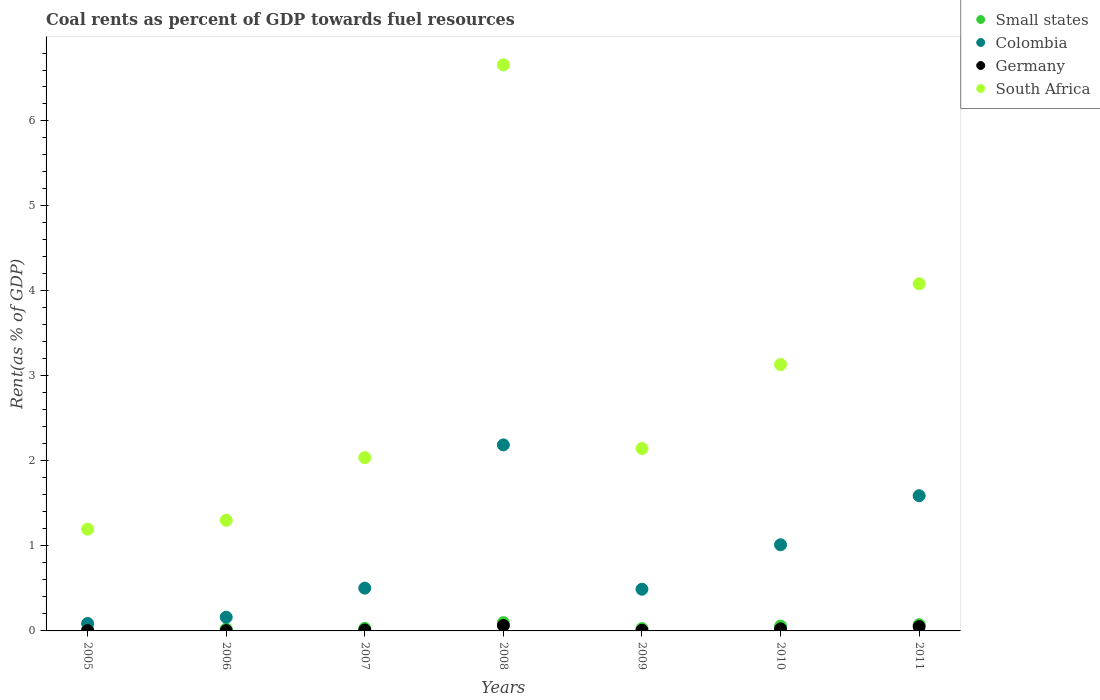How many different coloured dotlines are there?
Make the answer very short. 4. Is the number of dotlines equal to the number of legend labels?
Provide a succinct answer. Yes. What is the coal rent in Small states in 2009?
Keep it short and to the point. 0.03. Across all years, what is the maximum coal rent in Small states?
Offer a terse response. 0.1. Across all years, what is the minimum coal rent in Small states?
Provide a short and direct response. 0.02. In which year was the coal rent in South Africa minimum?
Provide a succinct answer. 2005. What is the total coal rent in Colombia in the graph?
Ensure brevity in your answer.  6.04. What is the difference between the coal rent in Colombia in 2008 and that in 2009?
Your answer should be compact. 1.7. What is the difference between the coal rent in Small states in 2006 and the coal rent in Germany in 2009?
Provide a short and direct response. 0.02. What is the average coal rent in Colombia per year?
Your response must be concise. 0.86. In the year 2005, what is the difference between the coal rent in Germany and coal rent in Small states?
Provide a short and direct response. -0.02. In how many years, is the coal rent in Colombia greater than 3.6 %?
Ensure brevity in your answer.  0. What is the ratio of the coal rent in Colombia in 2006 to that in 2011?
Ensure brevity in your answer.  0.1. Is the coal rent in Small states in 2006 less than that in 2011?
Give a very brief answer. Yes. Is the difference between the coal rent in Germany in 2007 and 2008 greater than the difference between the coal rent in Small states in 2007 and 2008?
Offer a terse response. Yes. What is the difference between the highest and the second highest coal rent in Small states?
Ensure brevity in your answer.  0.02. What is the difference between the highest and the lowest coal rent in Germany?
Your answer should be very brief. 0.06. In how many years, is the coal rent in Small states greater than the average coal rent in Small states taken over all years?
Your answer should be compact. 3. Is it the case that in every year, the sum of the coal rent in Germany and coal rent in South Africa  is greater than the sum of coal rent in Colombia and coal rent in Small states?
Keep it short and to the point. Yes. Does the coal rent in Small states monotonically increase over the years?
Offer a very short reply. No. Is the coal rent in Germany strictly greater than the coal rent in Small states over the years?
Your response must be concise. No. Is the coal rent in Small states strictly less than the coal rent in Colombia over the years?
Provide a short and direct response. Yes. How many dotlines are there?
Make the answer very short. 4. How many years are there in the graph?
Offer a terse response. 7. What is the difference between two consecutive major ticks on the Y-axis?
Provide a short and direct response. 1. Does the graph contain grids?
Make the answer very short. No. How are the legend labels stacked?
Ensure brevity in your answer.  Vertical. What is the title of the graph?
Offer a very short reply. Coal rents as percent of GDP towards fuel resources. What is the label or title of the X-axis?
Provide a short and direct response. Years. What is the label or title of the Y-axis?
Keep it short and to the point. Rent(as % of GDP). What is the Rent(as % of GDP) in Small states in 2005?
Your response must be concise. 0.02. What is the Rent(as % of GDP) in Colombia in 2005?
Your response must be concise. 0.09. What is the Rent(as % of GDP) of Germany in 2005?
Your answer should be very brief. 0. What is the Rent(as % of GDP) of South Africa in 2005?
Your answer should be very brief. 1.2. What is the Rent(as % of GDP) of Small states in 2006?
Keep it short and to the point. 0.02. What is the Rent(as % of GDP) in Colombia in 2006?
Your answer should be very brief. 0.16. What is the Rent(as % of GDP) of Germany in 2006?
Offer a very short reply. 0. What is the Rent(as % of GDP) of South Africa in 2006?
Make the answer very short. 1.3. What is the Rent(as % of GDP) in Small states in 2007?
Provide a short and direct response. 0.03. What is the Rent(as % of GDP) in Colombia in 2007?
Offer a terse response. 0.5. What is the Rent(as % of GDP) in Germany in 2007?
Make the answer very short. 0.01. What is the Rent(as % of GDP) of South Africa in 2007?
Provide a short and direct response. 2.04. What is the Rent(as % of GDP) of Small states in 2008?
Your response must be concise. 0.1. What is the Rent(as % of GDP) in Colombia in 2008?
Offer a terse response. 2.19. What is the Rent(as % of GDP) in Germany in 2008?
Your answer should be compact. 0.06. What is the Rent(as % of GDP) of South Africa in 2008?
Provide a succinct answer. 6.66. What is the Rent(as % of GDP) of Small states in 2009?
Provide a short and direct response. 0.03. What is the Rent(as % of GDP) in Colombia in 2009?
Your answer should be very brief. 0.49. What is the Rent(as % of GDP) of Germany in 2009?
Your answer should be very brief. 0.01. What is the Rent(as % of GDP) in South Africa in 2009?
Provide a short and direct response. 2.15. What is the Rent(as % of GDP) of Small states in 2010?
Offer a very short reply. 0.06. What is the Rent(as % of GDP) of Colombia in 2010?
Provide a succinct answer. 1.01. What is the Rent(as % of GDP) in Germany in 2010?
Your answer should be very brief. 0.02. What is the Rent(as % of GDP) of South Africa in 2010?
Your response must be concise. 3.13. What is the Rent(as % of GDP) in Small states in 2011?
Ensure brevity in your answer.  0.07. What is the Rent(as % of GDP) in Colombia in 2011?
Keep it short and to the point. 1.59. What is the Rent(as % of GDP) of Germany in 2011?
Your answer should be compact. 0.05. What is the Rent(as % of GDP) of South Africa in 2011?
Offer a very short reply. 4.08. Across all years, what is the maximum Rent(as % of GDP) in Small states?
Offer a very short reply. 0.1. Across all years, what is the maximum Rent(as % of GDP) in Colombia?
Offer a very short reply. 2.19. Across all years, what is the maximum Rent(as % of GDP) of Germany?
Keep it short and to the point. 0.06. Across all years, what is the maximum Rent(as % of GDP) in South Africa?
Your answer should be very brief. 6.66. Across all years, what is the minimum Rent(as % of GDP) in Small states?
Provide a succinct answer. 0.02. Across all years, what is the minimum Rent(as % of GDP) in Colombia?
Make the answer very short. 0.09. Across all years, what is the minimum Rent(as % of GDP) of Germany?
Ensure brevity in your answer.  0. Across all years, what is the minimum Rent(as % of GDP) in South Africa?
Give a very brief answer. 1.2. What is the total Rent(as % of GDP) of Small states in the graph?
Provide a short and direct response. 0.33. What is the total Rent(as % of GDP) in Colombia in the graph?
Make the answer very short. 6.04. What is the total Rent(as % of GDP) in Germany in the graph?
Provide a succinct answer. 0.16. What is the total Rent(as % of GDP) of South Africa in the graph?
Provide a succinct answer. 20.56. What is the difference between the Rent(as % of GDP) of Small states in 2005 and that in 2006?
Provide a succinct answer. -0. What is the difference between the Rent(as % of GDP) in Colombia in 2005 and that in 2006?
Give a very brief answer. -0.07. What is the difference between the Rent(as % of GDP) of Germany in 2005 and that in 2006?
Give a very brief answer. -0. What is the difference between the Rent(as % of GDP) in South Africa in 2005 and that in 2006?
Your answer should be compact. -0.1. What is the difference between the Rent(as % of GDP) of Small states in 2005 and that in 2007?
Ensure brevity in your answer.  -0.01. What is the difference between the Rent(as % of GDP) of Colombia in 2005 and that in 2007?
Make the answer very short. -0.42. What is the difference between the Rent(as % of GDP) of Germany in 2005 and that in 2007?
Your answer should be very brief. -0.01. What is the difference between the Rent(as % of GDP) of South Africa in 2005 and that in 2007?
Your answer should be compact. -0.84. What is the difference between the Rent(as % of GDP) in Small states in 2005 and that in 2008?
Make the answer very short. -0.08. What is the difference between the Rent(as % of GDP) of Colombia in 2005 and that in 2008?
Make the answer very short. -2.1. What is the difference between the Rent(as % of GDP) of Germany in 2005 and that in 2008?
Give a very brief answer. -0.06. What is the difference between the Rent(as % of GDP) of South Africa in 2005 and that in 2008?
Your response must be concise. -5.46. What is the difference between the Rent(as % of GDP) of Small states in 2005 and that in 2009?
Make the answer very short. -0.01. What is the difference between the Rent(as % of GDP) of Colombia in 2005 and that in 2009?
Make the answer very short. -0.4. What is the difference between the Rent(as % of GDP) of Germany in 2005 and that in 2009?
Ensure brevity in your answer.  -0. What is the difference between the Rent(as % of GDP) of South Africa in 2005 and that in 2009?
Ensure brevity in your answer.  -0.95. What is the difference between the Rent(as % of GDP) in Small states in 2005 and that in 2010?
Your answer should be compact. -0.04. What is the difference between the Rent(as % of GDP) of Colombia in 2005 and that in 2010?
Keep it short and to the point. -0.93. What is the difference between the Rent(as % of GDP) of Germany in 2005 and that in 2010?
Keep it short and to the point. -0.02. What is the difference between the Rent(as % of GDP) of South Africa in 2005 and that in 2010?
Your answer should be very brief. -1.94. What is the difference between the Rent(as % of GDP) in Small states in 2005 and that in 2011?
Provide a short and direct response. -0.05. What is the difference between the Rent(as % of GDP) in Colombia in 2005 and that in 2011?
Your answer should be compact. -1.5. What is the difference between the Rent(as % of GDP) of Germany in 2005 and that in 2011?
Make the answer very short. -0.05. What is the difference between the Rent(as % of GDP) of South Africa in 2005 and that in 2011?
Provide a short and direct response. -2.89. What is the difference between the Rent(as % of GDP) in Small states in 2006 and that in 2007?
Provide a succinct answer. -0.01. What is the difference between the Rent(as % of GDP) of Colombia in 2006 and that in 2007?
Your answer should be compact. -0.34. What is the difference between the Rent(as % of GDP) of Germany in 2006 and that in 2007?
Offer a very short reply. -0.01. What is the difference between the Rent(as % of GDP) in South Africa in 2006 and that in 2007?
Give a very brief answer. -0.74. What is the difference between the Rent(as % of GDP) of Small states in 2006 and that in 2008?
Your answer should be compact. -0.07. What is the difference between the Rent(as % of GDP) of Colombia in 2006 and that in 2008?
Provide a succinct answer. -2.03. What is the difference between the Rent(as % of GDP) of Germany in 2006 and that in 2008?
Offer a very short reply. -0.06. What is the difference between the Rent(as % of GDP) in South Africa in 2006 and that in 2008?
Provide a succinct answer. -5.36. What is the difference between the Rent(as % of GDP) of Small states in 2006 and that in 2009?
Provide a succinct answer. -0. What is the difference between the Rent(as % of GDP) in Colombia in 2006 and that in 2009?
Your answer should be very brief. -0.33. What is the difference between the Rent(as % of GDP) of Germany in 2006 and that in 2009?
Your answer should be very brief. -0. What is the difference between the Rent(as % of GDP) of South Africa in 2006 and that in 2009?
Provide a short and direct response. -0.84. What is the difference between the Rent(as % of GDP) of Small states in 2006 and that in 2010?
Your response must be concise. -0.03. What is the difference between the Rent(as % of GDP) of Colombia in 2006 and that in 2010?
Keep it short and to the point. -0.85. What is the difference between the Rent(as % of GDP) of Germany in 2006 and that in 2010?
Give a very brief answer. -0.02. What is the difference between the Rent(as % of GDP) in South Africa in 2006 and that in 2010?
Your answer should be very brief. -1.83. What is the difference between the Rent(as % of GDP) of Colombia in 2006 and that in 2011?
Your response must be concise. -1.43. What is the difference between the Rent(as % of GDP) in Germany in 2006 and that in 2011?
Offer a very short reply. -0.05. What is the difference between the Rent(as % of GDP) in South Africa in 2006 and that in 2011?
Your answer should be compact. -2.78. What is the difference between the Rent(as % of GDP) of Small states in 2007 and that in 2008?
Offer a very short reply. -0.07. What is the difference between the Rent(as % of GDP) of Colombia in 2007 and that in 2008?
Ensure brevity in your answer.  -1.69. What is the difference between the Rent(as % of GDP) in Germany in 2007 and that in 2008?
Make the answer very short. -0.05. What is the difference between the Rent(as % of GDP) in South Africa in 2007 and that in 2008?
Provide a succinct answer. -4.62. What is the difference between the Rent(as % of GDP) of Small states in 2007 and that in 2009?
Your answer should be very brief. 0. What is the difference between the Rent(as % of GDP) of Colombia in 2007 and that in 2009?
Offer a terse response. 0.01. What is the difference between the Rent(as % of GDP) of Germany in 2007 and that in 2009?
Your answer should be very brief. 0. What is the difference between the Rent(as % of GDP) of South Africa in 2007 and that in 2009?
Provide a succinct answer. -0.11. What is the difference between the Rent(as % of GDP) of Small states in 2007 and that in 2010?
Your answer should be compact. -0.03. What is the difference between the Rent(as % of GDP) in Colombia in 2007 and that in 2010?
Provide a short and direct response. -0.51. What is the difference between the Rent(as % of GDP) of Germany in 2007 and that in 2010?
Ensure brevity in your answer.  -0.01. What is the difference between the Rent(as % of GDP) in South Africa in 2007 and that in 2010?
Offer a very short reply. -1.1. What is the difference between the Rent(as % of GDP) of Small states in 2007 and that in 2011?
Keep it short and to the point. -0.04. What is the difference between the Rent(as % of GDP) of Colombia in 2007 and that in 2011?
Offer a terse response. -1.09. What is the difference between the Rent(as % of GDP) in Germany in 2007 and that in 2011?
Give a very brief answer. -0.04. What is the difference between the Rent(as % of GDP) in South Africa in 2007 and that in 2011?
Keep it short and to the point. -2.05. What is the difference between the Rent(as % of GDP) in Small states in 2008 and that in 2009?
Your answer should be compact. 0.07. What is the difference between the Rent(as % of GDP) in Colombia in 2008 and that in 2009?
Keep it short and to the point. 1.7. What is the difference between the Rent(as % of GDP) of Germany in 2008 and that in 2009?
Provide a succinct answer. 0.06. What is the difference between the Rent(as % of GDP) of South Africa in 2008 and that in 2009?
Offer a very short reply. 4.51. What is the difference between the Rent(as % of GDP) of Small states in 2008 and that in 2010?
Your response must be concise. 0.04. What is the difference between the Rent(as % of GDP) in Colombia in 2008 and that in 2010?
Your response must be concise. 1.18. What is the difference between the Rent(as % of GDP) in Germany in 2008 and that in 2010?
Your answer should be compact. 0.04. What is the difference between the Rent(as % of GDP) in South Africa in 2008 and that in 2010?
Your answer should be compact. 3.53. What is the difference between the Rent(as % of GDP) in Small states in 2008 and that in 2011?
Ensure brevity in your answer.  0.02. What is the difference between the Rent(as % of GDP) of Colombia in 2008 and that in 2011?
Give a very brief answer. 0.6. What is the difference between the Rent(as % of GDP) of Germany in 2008 and that in 2011?
Give a very brief answer. 0.01. What is the difference between the Rent(as % of GDP) in South Africa in 2008 and that in 2011?
Your response must be concise. 2.58. What is the difference between the Rent(as % of GDP) of Small states in 2009 and that in 2010?
Ensure brevity in your answer.  -0.03. What is the difference between the Rent(as % of GDP) of Colombia in 2009 and that in 2010?
Provide a short and direct response. -0.52. What is the difference between the Rent(as % of GDP) in Germany in 2009 and that in 2010?
Provide a short and direct response. -0.02. What is the difference between the Rent(as % of GDP) in South Africa in 2009 and that in 2010?
Provide a short and direct response. -0.99. What is the difference between the Rent(as % of GDP) of Small states in 2009 and that in 2011?
Make the answer very short. -0.05. What is the difference between the Rent(as % of GDP) in Colombia in 2009 and that in 2011?
Your answer should be compact. -1.1. What is the difference between the Rent(as % of GDP) of Germany in 2009 and that in 2011?
Provide a short and direct response. -0.04. What is the difference between the Rent(as % of GDP) in South Africa in 2009 and that in 2011?
Offer a very short reply. -1.94. What is the difference between the Rent(as % of GDP) in Small states in 2010 and that in 2011?
Provide a succinct answer. -0.02. What is the difference between the Rent(as % of GDP) in Colombia in 2010 and that in 2011?
Ensure brevity in your answer.  -0.58. What is the difference between the Rent(as % of GDP) of Germany in 2010 and that in 2011?
Ensure brevity in your answer.  -0.03. What is the difference between the Rent(as % of GDP) in South Africa in 2010 and that in 2011?
Offer a very short reply. -0.95. What is the difference between the Rent(as % of GDP) in Small states in 2005 and the Rent(as % of GDP) in Colombia in 2006?
Provide a short and direct response. -0.14. What is the difference between the Rent(as % of GDP) in Small states in 2005 and the Rent(as % of GDP) in Germany in 2006?
Offer a terse response. 0.02. What is the difference between the Rent(as % of GDP) in Small states in 2005 and the Rent(as % of GDP) in South Africa in 2006?
Provide a succinct answer. -1.28. What is the difference between the Rent(as % of GDP) in Colombia in 2005 and the Rent(as % of GDP) in Germany in 2006?
Your answer should be compact. 0.08. What is the difference between the Rent(as % of GDP) in Colombia in 2005 and the Rent(as % of GDP) in South Africa in 2006?
Offer a terse response. -1.21. What is the difference between the Rent(as % of GDP) in Germany in 2005 and the Rent(as % of GDP) in South Africa in 2006?
Your answer should be compact. -1.3. What is the difference between the Rent(as % of GDP) in Small states in 2005 and the Rent(as % of GDP) in Colombia in 2007?
Your answer should be compact. -0.48. What is the difference between the Rent(as % of GDP) in Small states in 2005 and the Rent(as % of GDP) in Germany in 2007?
Make the answer very short. 0.01. What is the difference between the Rent(as % of GDP) of Small states in 2005 and the Rent(as % of GDP) of South Africa in 2007?
Provide a short and direct response. -2.02. What is the difference between the Rent(as % of GDP) of Colombia in 2005 and the Rent(as % of GDP) of Germany in 2007?
Your response must be concise. 0.08. What is the difference between the Rent(as % of GDP) of Colombia in 2005 and the Rent(as % of GDP) of South Africa in 2007?
Offer a very short reply. -1.95. What is the difference between the Rent(as % of GDP) in Germany in 2005 and the Rent(as % of GDP) in South Africa in 2007?
Give a very brief answer. -2.04. What is the difference between the Rent(as % of GDP) in Small states in 2005 and the Rent(as % of GDP) in Colombia in 2008?
Your answer should be compact. -2.17. What is the difference between the Rent(as % of GDP) of Small states in 2005 and the Rent(as % of GDP) of Germany in 2008?
Give a very brief answer. -0.04. What is the difference between the Rent(as % of GDP) of Small states in 2005 and the Rent(as % of GDP) of South Africa in 2008?
Your response must be concise. -6.64. What is the difference between the Rent(as % of GDP) in Colombia in 2005 and the Rent(as % of GDP) in Germany in 2008?
Keep it short and to the point. 0.02. What is the difference between the Rent(as % of GDP) of Colombia in 2005 and the Rent(as % of GDP) of South Africa in 2008?
Your response must be concise. -6.57. What is the difference between the Rent(as % of GDP) in Germany in 2005 and the Rent(as % of GDP) in South Africa in 2008?
Your response must be concise. -6.66. What is the difference between the Rent(as % of GDP) in Small states in 2005 and the Rent(as % of GDP) in Colombia in 2009?
Give a very brief answer. -0.47. What is the difference between the Rent(as % of GDP) in Small states in 2005 and the Rent(as % of GDP) in Germany in 2009?
Provide a succinct answer. 0.01. What is the difference between the Rent(as % of GDP) of Small states in 2005 and the Rent(as % of GDP) of South Africa in 2009?
Your response must be concise. -2.13. What is the difference between the Rent(as % of GDP) in Colombia in 2005 and the Rent(as % of GDP) in Germany in 2009?
Give a very brief answer. 0.08. What is the difference between the Rent(as % of GDP) in Colombia in 2005 and the Rent(as % of GDP) in South Africa in 2009?
Your answer should be compact. -2.06. What is the difference between the Rent(as % of GDP) in Germany in 2005 and the Rent(as % of GDP) in South Africa in 2009?
Your answer should be compact. -2.14. What is the difference between the Rent(as % of GDP) in Small states in 2005 and the Rent(as % of GDP) in Colombia in 2010?
Offer a terse response. -0.99. What is the difference between the Rent(as % of GDP) of Small states in 2005 and the Rent(as % of GDP) of Germany in 2010?
Your response must be concise. -0. What is the difference between the Rent(as % of GDP) of Small states in 2005 and the Rent(as % of GDP) of South Africa in 2010?
Your answer should be compact. -3.11. What is the difference between the Rent(as % of GDP) in Colombia in 2005 and the Rent(as % of GDP) in Germany in 2010?
Your answer should be very brief. 0.06. What is the difference between the Rent(as % of GDP) of Colombia in 2005 and the Rent(as % of GDP) of South Africa in 2010?
Make the answer very short. -3.05. What is the difference between the Rent(as % of GDP) of Germany in 2005 and the Rent(as % of GDP) of South Africa in 2010?
Keep it short and to the point. -3.13. What is the difference between the Rent(as % of GDP) in Small states in 2005 and the Rent(as % of GDP) in Colombia in 2011?
Make the answer very short. -1.57. What is the difference between the Rent(as % of GDP) of Small states in 2005 and the Rent(as % of GDP) of Germany in 2011?
Ensure brevity in your answer.  -0.03. What is the difference between the Rent(as % of GDP) in Small states in 2005 and the Rent(as % of GDP) in South Africa in 2011?
Provide a succinct answer. -4.06. What is the difference between the Rent(as % of GDP) of Colombia in 2005 and the Rent(as % of GDP) of Germany in 2011?
Make the answer very short. 0.04. What is the difference between the Rent(as % of GDP) in Colombia in 2005 and the Rent(as % of GDP) in South Africa in 2011?
Make the answer very short. -4. What is the difference between the Rent(as % of GDP) in Germany in 2005 and the Rent(as % of GDP) in South Africa in 2011?
Your response must be concise. -4.08. What is the difference between the Rent(as % of GDP) in Small states in 2006 and the Rent(as % of GDP) in Colombia in 2007?
Your answer should be compact. -0.48. What is the difference between the Rent(as % of GDP) of Small states in 2006 and the Rent(as % of GDP) of Germany in 2007?
Your response must be concise. 0.01. What is the difference between the Rent(as % of GDP) in Small states in 2006 and the Rent(as % of GDP) in South Africa in 2007?
Ensure brevity in your answer.  -2.02. What is the difference between the Rent(as % of GDP) in Colombia in 2006 and the Rent(as % of GDP) in Germany in 2007?
Give a very brief answer. 0.15. What is the difference between the Rent(as % of GDP) of Colombia in 2006 and the Rent(as % of GDP) of South Africa in 2007?
Provide a succinct answer. -1.88. What is the difference between the Rent(as % of GDP) of Germany in 2006 and the Rent(as % of GDP) of South Africa in 2007?
Your answer should be very brief. -2.04. What is the difference between the Rent(as % of GDP) in Small states in 2006 and the Rent(as % of GDP) in Colombia in 2008?
Keep it short and to the point. -2.17. What is the difference between the Rent(as % of GDP) in Small states in 2006 and the Rent(as % of GDP) in Germany in 2008?
Keep it short and to the point. -0.04. What is the difference between the Rent(as % of GDP) in Small states in 2006 and the Rent(as % of GDP) in South Africa in 2008?
Ensure brevity in your answer.  -6.64. What is the difference between the Rent(as % of GDP) of Colombia in 2006 and the Rent(as % of GDP) of Germany in 2008?
Make the answer very short. 0.1. What is the difference between the Rent(as % of GDP) of Colombia in 2006 and the Rent(as % of GDP) of South Africa in 2008?
Offer a very short reply. -6.5. What is the difference between the Rent(as % of GDP) of Germany in 2006 and the Rent(as % of GDP) of South Africa in 2008?
Keep it short and to the point. -6.66. What is the difference between the Rent(as % of GDP) of Small states in 2006 and the Rent(as % of GDP) of Colombia in 2009?
Offer a very short reply. -0.47. What is the difference between the Rent(as % of GDP) in Small states in 2006 and the Rent(as % of GDP) in Germany in 2009?
Keep it short and to the point. 0.02. What is the difference between the Rent(as % of GDP) of Small states in 2006 and the Rent(as % of GDP) of South Africa in 2009?
Offer a terse response. -2.12. What is the difference between the Rent(as % of GDP) in Colombia in 2006 and the Rent(as % of GDP) in Germany in 2009?
Offer a terse response. 0.15. What is the difference between the Rent(as % of GDP) of Colombia in 2006 and the Rent(as % of GDP) of South Africa in 2009?
Provide a succinct answer. -1.99. What is the difference between the Rent(as % of GDP) of Germany in 2006 and the Rent(as % of GDP) of South Africa in 2009?
Provide a succinct answer. -2.14. What is the difference between the Rent(as % of GDP) of Small states in 2006 and the Rent(as % of GDP) of Colombia in 2010?
Your answer should be very brief. -0.99. What is the difference between the Rent(as % of GDP) in Small states in 2006 and the Rent(as % of GDP) in Germany in 2010?
Ensure brevity in your answer.  -0. What is the difference between the Rent(as % of GDP) of Small states in 2006 and the Rent(as % of GDP) of South Africa in 2010?
Offer a very short reply. -3.11. What is the difference between the Rent(as % of GDP) of Colombia in 2006 and the Rent(as % of GDP) of Germany in 2010?
Give a very brief answer. 0.14. What is the difference between the Rent(as % of GDP) in Colombia in 2006 and the Rent(as % of GDP) in South Africa in 2010?
Your answer should be compact. -2.97. What is the difference between the Rent(as % of GDP) of Germany in 2006 and the Rent(as % of GDP) of South Africa in 2010?
Ensure brevity in your answer.  -3.13. What is the difference between the Rent(as % of GDP) in Small states in 2006 and the Rent(as % of GDP) in Colombia in 2011?
Give a very brief answer. -1.57. What is the difference between the Rent(as % of GDP) in Small states in 2006 and the Rent(as % of GDP) in Germany in 2011?
Provide a short and direct response. -0.03. What is the difference between the Rent(as % of GDP) of Small states in 2006 and the Rent(as % of GDP) of South Africa in 2011?
Make the answer very short. -4.06. What is the difference between the Rent(as % of GDP) in Colombia in 2006 and the Rent(as % of GDP) in Germany in 2011?
Provide a succinct answer. 0.11. What is the difference between the Rent(as % of GDP) in Colombia in 2006 and the Rent(as % of GDP) in South Africa in 2011?
Your answer should be compact. -3.92. What is the difference between the Rent(as % of GDP) in Germany in 2006 and the Rent(as % of GDP) in South Africa in 2011?
Ensure brevity in your answer.  -4.08. What is the difference between the Rent(as % of GDP) in Small states in 2007 and the Rent(as % of GDP) in Colombia in 2008?
Your answer should be very brief. -2.16. What is the difference between the Rent(as % of GDP) of Small states in 2007 and the Rent(as % of GDP) of Germany in 2008?
Your answer should be compact. -0.03. What is the difference between the Rent(as % of GDP) in Small states in 2007 and the Rent(as % of GDP) in South Africa in 2008?
Keep it short and to the point. -6.63. What is the difference between the Rent(as % of GDP) of Colombia in 2007 and the Rent(as % of GDP) of Germany in 2008?
Make the answer very short. 0.44. What is the difference between the Rent(as % of GDP) of Colombia in 2007 and the Rent(as % of GDP) of South Africa in 2008?
Offer a very short reply. -6.16. What is the difference between the Rent(as % of GDP) of Germany in 2007 and the Rent(as % of GDP) of South Africa in 2008?
Your answer should be compact. -6.65. What is the difference between the Rent(as % of GDP) in Small states in 2007 and the Rent(as % of GDP) in Colombia in 2009?
Offer a very short reply. -0.46. What is the difference between the Rent(as % of GDP) in Small states in 2007 and the Rent(as % of GDP) in Germany in 2009?
Keep it short and to the point. 0.02. What is the difference between the Rent(as % of GDP) of Small states in 2007 and the Rent(as % of GDP) of South Africa in 2009?
Provide a succinct answer. -2.12. What is the difference between the Rent(as % of GDP) in Colombia in 2007 and the Rent(as % of GDP) in Germany in 2009?
Ensure brevity in your answer.  0.5. What is the difference between the Rent(as % of GDP) in Colombia in 2007 and the Rent(as % of GDP) in South Africa in 2009?
Provide a short and direct response. -1.64. What is the difference between the Rent(as % of GDP) of Germany in 2007 and the Rent(as % of GDP) of South Africa in 2009?
Keep it short and to the point. -2.14. What is the difference between the Rent(as % of GDP) of Small states in 2007 and the Rent(as % of GDP) of Colombia in 2010?
Your response must be concise. -0.98. What is the difference between the Rent(as % of GDP) in Small states in 2007 and the Rent(as % of GDP) in Germany in 2010?
Offer a terse response. 0.01. What is the difference between the Rent(as % of GDP) of Small states in 2007 and the Rent(as % of GDP) of South Africa in 2010?
Give a very brief answer. -3.1. What is the difference between the Rent(as % of GDP) in Colombia in 2007 and the Rent(as % of GDP) in Germany in 2010?
Keep it short and to the point. 0.48. What is the difference between the Rent(as % of GDP) in Colombia in 2007 and the Rent(as % of GDP) in South Africa in 2010?
Provide a short and direct response. -2.63. What is the difference between the Rent(as % of GDP) in Germany in 2007 and the Rent(as % of GDP) in South Africa in 2010?
Offer a very short reply. -3.12. What is the difference between the Rent(as % of GDP) in Small states in 2007 and the Rent(as % of GDP) in Colombia in 2011?
Your response must be concise. -1.56. What is the difference between the Rent(as % of GDP) of Small states in 2007 and the Rent(as % of GDP) of Germany in 2011?
Ensure brevity in your answer.  -0.02. What is the difference between the Rent(as % of GDP) in Small states in 2007 and the Rent(as % of GDP) in South Africa in 2011?
Give a very brief answer. -4.05. What is the difference between the Rent(as % of GDP) of Colombia in 2007 and the Rent(as % of GDP) of Germany in 2011?
Make the answer very short. 0.45. What is the difference between the Rent(as % of GDP) in Colombia in 2007 and the Rent(as % of GDP) in South Africa in 2011?
Offer a terse response. -3.58. What is the difference between the Rent(as % of GDP) in Germany in 2007 and the Rent(as % of GDP) in South Africa in 2011?
Provide a short and direct response. -4.07. What is the difference between the Rent(as % of GDP) of Small states in 2008 and the Rent(as % of GDP) of Colombia in 2009?
Ensure brevity in your answer.  -0.39. What is the difference between the Rent(as % of GDP) in Small states in 2008 and the Rent(as % of GDP) in Germany in 2009?
Provide a short and direct response. 0.09. What is the difference between the Rent(as % of GDP) in Small states in 2008 and the Rent(as % of GDP) in South Africa in 2009?
Give a very brief answer. -2.05. What is the difference between the Rent(as % of GDP) of Colombia in 2008 and the Rent(as % of GDP) of Germany in 2009?
Give a very brief answer. 2.18. What is the difference between the Rent(as % of GDP) in Colombia in 2008 and the Rent(as % of GDP) in South Africa in 2009?
Offer a very short reply. 0.04. What is the difference between the Rent(as % of GDP) in Germany in 2008 and the Rent(as % of GDP) in South Africa in 2009?
Ensure brevity in your answer.  -2.08. What is the difference between the Rent(as % of GDP) of Small states in 2008 and the Rent(as % of GDP) of Colombia in 2010?
Offer a very short reply. -0.92. What is the difference between the Rent(as % of GDP) of Small states in 2008 and the Rent(as % of GDP) of Germany in 2010?
Give a very brief answer. 0.07. What is the difference between the Rent(as % of GDP) of Small states in 2008 and the Rent(as % of GDP) of South Africa in 2010?
Keep it short and to the point. -3.04. What is the difference between the Rent(as % of GDP) in Colombia in 2008 and the Rent(as % of GDP) in Germany in 2010?
Your answer should be compact. 2.17. What is the difference between the Rent(as % of GDP) of Colombia in 2008 and the Rent(as % of GDP) of South Africa in 2010?
Make the answer very short. -0.95. What is the difference between the Rent(as % of GDP) in Germany in 2008 and the Rent(as % of GDP) in South Africa in 2010?
Make the answer very short. -3.07. What is the difference between the Rent(as % of GDP) in Small states in 2008 and the Rent(as % of GDP) in Colombia in 2011?
Provide a succinct answer. -1.49. What is the difference between the Rent(as % of GDP) of Small states in 2008 and the Rent(as % of GDP) of Germany in 2011?
Offer a terse response. 0.05. What is the difference between the Rent(as % of GDP) of Small states in 2008 and the Rent(as % of GDP) of South Africa in 2011?
Offer a very short reply. -3.99. What is the difference between the Rent(as % of GDP) in Colombia in 2008 and the Rent(as % of GDP) in Germany in 2011?
Ensure brevity in your answer.  2.14. What is the difference between the Rent(as % of GDP) in Colombia in 2008 and the Rent(as % of GDP) in South Africa in 2011?
Provide a succinct answer. -1.9. What is the difference between the Rent(as % of GDP) of Germany in 2008 and the Rent(as % of GDP) of South Africa in 2011?
Offer a terse response. -4.02. What is the difference between the Rent(as % of GDP) of Small states in 2009 and the Rent(as % of GDP) of Colombia in 2010?
Provide a succinct answer. -0.99. What is the difference between the Rent(as % of GDP) in Small states in 2009 and the Rent(as % of GDP) in Germany in 2010?
Make the answer very short. 0. What is the difference between the Rent(as % of GDP) of Small states in 2009 and the Rent(as % of GDP) of South Africa in 2010?
Give a very brief answer. -3.11. What is the difference between the Rent(as % of GDP) in Colombia in 2009 and the Rent(as % of GDP) in Germany in 2010?
Give a very brief answer. 0.47. What is the difference between the Rent(as % of GDP) in Colombia in 2009 and the Rent(as % of GDP) in South Africa in 2010?
Offer a very short reply. -2.64. What is the difference between the Rent(as % of GDP) in Germany in 2009 and the Rent(as % of GDP) in South Africa in 2010?
Keep it short and to the point. -3.13. What is the difference between the Rent(as % of GDP) of Small states in 2009 and the Rent(as % of GDP) of Colombia in 2011?
Offer a very short reply. -1.56. What is the difference between the Rent(as % of GDP) of Small states in 2009 and the Rent(as % of GDP) of Germany in 2011?
Your answer should be compact. -0.02. What is the difference between the Rent(as % of GDP) of Small states in 2009 and the Rent(as % of GDP) of South Africa in 2011?
Your answer should be compact. -4.06. What is the difference between the Rent(as % of GDP) of Colombia in 2009 and the Rent(as % of GDP) of Germany in 2011?
Offer a terse response. 0.44. What is the difference between the Rent(as % of GDP) in Colombia in 2009 and the Rent(as % of GDP) in South Africa in 2011?
Keep it short and to the point. -3.59. What is the difference between the Rent(as % of GDP) of Germany in 2009 and the Rent(as % of GDP) of South Africa in 2011?
Keep it short and to the point. -4.08. What is the difference between the Rent(as % of GDP) of Small states in 2010 and the Rent(as % of GDP) of Colombia in 2011?
Make the answer very short. -1.53. What is the difference between the Rent(as % of GDP) of Small states in 2010 and the Rent(as % of GDP) of Germany in 2011?
Make the answer very short. 0.01. What is the difference between the Rent(as % of GDP) in Small states in 2010 and the Rent(as % of GDP) in South Africa in 2011?
Ensure brevity in your answer.  -4.03. What is the difference between the Rent(as % of GDP) of Colombia in 2010 and the Rent(as % of GDP) of Germany in 2011?
Your answer should be very brief. 0.96. What is the difference between the Rent(as % of GDP) of Colombia in 2010 and the Rent(as % of GDP) of South Africa in 2011?
Ensure brevity in your answer.  -3.07. What is the difference between the Rent(as % of GDP) in Germany in 2010 and the Rent(as % of GDP) in South Africa in 2011?
Make the answer very short. -4.06. What is the average Rent(as % of GDP) of Small states per year?
Offer a terse response. 0.05. What is the average Rent(as % of GDP) of Colombia per year?
Ensure brevity in your answer.  0.86. What is the average Rent(as % of GDP) in Germany per year?
Your response must be concise. 0.02. What is the average Rent(as % of GDP) in South Africa per year?
Keep it short and to the point. 2.94. In the year 2005, what is the difference between the Rent(as % of GDP) in Small states and Rent(as % of GDP) in Colombia?
Offer a terse response. -0.07. In the year 2005, what is the difference between the Rent(as % of GDP) of Small states and Rent(as % of GDP) of Germany?
Offer a terse response. 0.02. In the year 2005, what is the difference between the Rent(as % of GDP) in Small states and Rent(as % of GDP) in South Africa?
Provide a succinct answer. -1.18. In the year 2005, what is the difference between the Rent(as % of GDP) in Colombia and Rent(as % of GDP) in Germany?
Make the answer very short. 0.08. In the year 2005, what is the difference between the Rent(as % of GDP) in Colombia and Rent(as % of GDP) in South Africa?
Your answer should be compact. -1.11. In the year 2005, what is the difference between the Rent(as % of GDP) in Germany and Rent(as % of GDP) in South Africa?
Ensure brevity in your answer.  -1.19. In the year 2006, what is the difference between the Rent(as % of GDP) in Small states and Rent(as % of GDP) in Colombia?
Provide a short and direct response. -0.14. In the year 2006, what is the difference between the Rent(as % of GDP) of Small states and Rent(as % of GDP) of Germany?
Your answer should be very brief. 0.02. In the year 2006, what is the difference between the Rent(as % of GDP) in Small states and Rent(as % of GDP) in South Africa?
Give a very brief answer. -1.28. In the year 2006, what is the difference between the Rent(as % of GDP) of Colombia and Rent(as % of GDP) of Germany?
Provide a succinct answer. 0.16. In the year 2006, what is the difference between the Rent(as % of GDP) of Colombia and Rent(as % of GDP) of South Africa?
Make the answer very short. -1.14. In the year 2006, what is the difference between the Rent(as % of GDP) in Germany and Rent(as % of GDP) in South Africa?
Make the answer very short. -1.3. In the year 2007, what is the difference between the Rent(as % of GDP) of Small states and Rent(as % of GDP) of Colombia?
Offer a very short reply. -0.47. In the year 2007, what is the difference between the Rent(as % of GDP) of Small states and Rent(as % of GDP) of Germany?
Your answer should be compact. 0.02. In the year 2007, what is the difference between the Rent(as % of GDP) of Small states and Rent(as % of GDP) of South Africa?
Provide a succinct answer. -2.01. In the year 2007, what is the difference between the Rent(as % of GDP) in Colombia and Rent(as % of GDP) in Germany?
Provide a succinct answer. 0.49. In the year 2007, what is the difference between the Rent(as % of GDP) of Colombia and Rent(as % of GDP) of South Africa?
Give a very brief answer. -1.54. In the year 2007, what is the difference between the Rent(as % of GDP) in Germany and Rent(as % of GDP) in South Africa?
Keep it short and to the point. -2.03. In the year 2008, what is the difference between the Rent(as % of GDP) of Small states and Rent(as % of GDP) of Colombia?
Ensure brevity in your answer.  -2.09. In the year 2008, what is the difference between the Rent(as % of GDP) in Small states and Rent(as % of GDP) in Germany?
Make the answer very short. 0.03. In the year 2008, what is the difference between the Rent(as % of GDP) in Small states and Rent(as % of GDP) in South Africa?
Provide a succinct answer. -6.56. In the year 2008, what is the difference between the Rent(as % of GDP) in Colombia and Rent(as % of GDP) in Germany?
Provide a succinct answer. 2.12. In the year 2008, what is the difference between the Rent(as % of GDP) in Colombia and Rent(as % of GDP) in South Africa?
Your response must be concise. -4.47. In the year 2008, what is the difference between the Rent(as % of GDP) in Germany and Rent(as % of GDP) in South Africa?
Your answer should be very brief. -6.6. In the year 2009, what is the difference between the Rent(as % of GDP) of Small states and Rent(as % of GDP) of Colombia?
Provide a succinct answer. -0.46. In the year 2009, what is the difference between the Rent(as % of GDP) of Small states and Rent(as % of GDP) of Germany?
Provide a short and direct response. 0.02. In the year 2009, what is the difference between the Rent(as % of GDP) of Small states and Rent(as % of GDP) of South Africa?
Offer a terse response. -2.12. In the year 2009, what is the difference between the Rent(as % of GDP) in Colombia and Rent(as % of GDP) in Germany?
Offer a very short reply. 0.48. In the year 2009, what is the difference between the Rent(as % of GDP) of Colombia and Rent(as % of GDP) of South Africa?
Provide a short and direct response. -1.66. In the year 2009, what is the difference between the Rent(as % of GDP) in Germany and Rent(as % of GDP) in South Africa?
Offer a terse response. -2.14. In the year 2010, what is the difference between the Rent(as % of GDP) of Small states and Rent(as % of GDP) of Colombia?
Provide a short and direct response. -0.96. In the year 2010, what is the difference between the Rent(as % of GDP) of Small states and Rent(as % of GDP) of Germany?
Give a very brief answer. 0.03. In the year 2010, what is the difference between the Rent(as % of GDP) of Small states and Rent(as % of GDP) of South Africa?
Your answer should be very brief. -3.08. In the year 2010, what is the difference between the Rent(as % of GDP) in Colombia and Rent(as % of GDP) in Germany?
Provide a succinct answer. 0.99. In the year 2010, what is the difference between the Rent(as % of GDP) of Colombia and Rent(as % of GDP) of South Africa?
Your response must be concise. -2.12. In the year 2010, what is the difference between the Rent(as % of GDP) in Germany and Rent(as % of GDP) in South Africa?
Offer a terse response. -3.11. In the year 2011, what is the difference between the Rent(as % of GDP) of Small states and Rent(as % of GDP) of Colombia?
Provide a short and direct response. -1.52. In the year 2011, what is the difference between the Rent(as % of GDP) of Small states and Rent(as % of GDP) of Germany?
Keep it short and to the point. 0.02. In the year 2011, what is the difference between the Rent(as % of GDP) in Small states and Rent(as % of GDP) in South Africa?
Your answer should be very brief. -4.01. In the year 2011, what is the difference between the Rent(as % of GDP) in Colombia and Rent(as % of GDP) in Germany?
Ensure brevity in your answer.  1.54. In the year 2011, what is the difference between the Rent(as % of GDP) of Colombia and Rent(as % of GDP) of South Africa?
Your answer should be very brief. -2.49. In the year 2011, what is the difference between the Rent(as % of GDP) in Germany and Rent(as % of GDP) in South Africa?
Ensure brevity in your answer.  -4.03. What is the ratio of the Rent(as % of GDP) of Small states in 2005 to that in 2006?
Give a very brief answer. 0.93. What is the ratio of the Rent(as % of GDP) in Colombia in 2005 to that in 2006?
Ensure brevity in your answer.  0.54. What is the ratio of the Rent(as % of GDP) in Germany in 2005 to that in 2006?
Offer a very short reply. 0.77. What is the ratio of the Rent(as % of GDP) in South Africa in 2005 to that in 2006?
Offer a terse response. 0.92. What is the ratio of the Rent(as % of GDP) of Small states in 2005 to that in 2007?
Offer a very short reply. 0.72. What is the ratio of the Rent(as % of GDP) in Colombia in 2005 to that in 2007?
Make the answer very short. 0.17. What is the ratio of the Rent(as % of GDP) of Germany in 2005 to that in 2007?
Your answer should be very brief. 0.27. What is the ratio of the Rent(as % of GDP) in South Africa in 2005 to that in 2007?
Offer a terse response. 0.59. What is the ratio of the Rent(as % of GDP) of Small states in 2005 to that in 2008?
Your answer should be very brief. 0.22. What is the ratio of the Rent(as % of GDP) in Colombia in 2005 to that in 2008?
Keep it short and to the point. 0.04. What is the ratio of the Rent(as % of GDP) of Germany in 2005 to that in 2008?
Ensure brevity in your answer.  0.05. What is the ratio of the Rent(as % of GDP) of South Africa in 2005 to that in 2008?
Offer a very short reply. 0.18. What is the ratio of the Rent(as % of GDP) of Small states in 2005 to that in 2009?
Make the answer very short. 0.8. What is the ratio of the Rent(as % of GDP) in Colombia in 2005 to that in 2009?
Make the answer very short. 0.18. What is the ratio of the Rent(as % of GDP) of Germany in 2005 to that in 2009?
Give a very brief answer. 0.4. What is the ratio of the Rent(as % of GDP) in South Africa in 2005 to that in 2009?
Your answer should be very brief. 0.56. What is the ratio of the Rent(as % of GDP) of Small states in 2005 to that in 2010?
Your response must be concise. 0.38. What is the ratio of the Rent(as % of GDP) in Colombia in 2005 to that in 2010?
Keep it short and to the point. 0.09. What is the ratio of the Rent(as % of GDP) in Germany in 2005 to that in 2010?
Offer a very short reply. 0.13. What is the ratio of the Rent(as % of GDP) of South Africa in 2005 to that in 2010?
Your answer should be very brief. 0.38. What is the ratio of the Rent(as % of GDP) of Small states in 2005 to that in 2011?
Your answer should be compact. 0.29. What is the ratio of the Rent(as % of GDP) in Colombia in 2005 to that in 2011?
Make the answer very short. 0.06. What is the ratio of the Rent(as % of GDP) of Germany in 2005 to that in 2011?
Provide a short and direct response. 0.06. What is the ratio of the Rent(as % of GDP) of South Africa in 2005 to that in 2011?
Ensure brevity in your answer.  0.29. What is the ratio of the Rent(as % of GDP) of Small states in 2006 to that in 2007?
Offer a terse response. 0.77. What is the ratio of the Rent(as % of GDP) of Colombia in 2006 to that in 2007?
Give a very brief answer. 0.32. What is the ratio of the Rent(as % of GDP) in Germany in 2006 to that in 2007?
Ensure brevity in your answer.  0.35. What is the ratio of the Rent(as % of GDP) in South Africa in 2006 to that in 2007?
Offer a terse response. 0.64. What is the ratio of the Rent(as % of GDP) in Small states in 2006 to that in 2008?
Your answer should be very brief. 0.24. What is the ratio of the Rent(as % of GDP) in Colombia in 2006 to that in 2008?
Give a very brief answer. 0.07. What is the ratio of the Rent(as % of GDP) in Germany in 2006 to that in 2008?
Provide a short and direct response. 0.06. What is the ratio of the Rent(as % of GDP) of South Africa in 2006 to that in 2008?
Offer a terse response. 0.2. What is the ratio of the Rent(as % of GDP) of Small states in 2006 to that in 2009?
Make the answer very short. 0.85. What is the ratio of the Rent(as % of GDP) in Colombia in 2006 to that in 2009?
Give a very brief answer. 0.33. What is the ratio of the Rent(as % of GDP) in Germany in 2006 to that in 2009?
Give a very brief answer. 0.52. What is the ratio of the Rent(as % of GDP) in South Africa in 2006 to that in 2009?
Offer a terse response. 0.61. What is the ratio of the Rent(as % of GDP) in Small states in 2006 to that in 2010?
Your answer should be compact. 0.41. What is the ratio of the Rent(as % of GDP) in Colombia in 2006 to that in 2010?
Your answer should be very brief. 0.16. What is the ratio of the Rent(as % of GDP) in Germany in 2006 to that in 2010?
Offer a terse response. 0.16. What is the ratio of the Rent(as % of GDP) of South Africa in 2006 to that in 2010?
Make the answer very short. 0.42. What is the ratio of the Rent(as % of GDP) of Small states in 2006 to that in 2011?
Offer a terse response. 0.32. What is the ratio of the Rent(as % of GDP) of Colombia in 2006 to that in 2011?
Your answer should be compact. 0.1. What is the ratio of the Rent(as % of GDP) in Germany in 2006 to that in 2011?
Offer a very short reply. 0.08. What is the ratio of the Rent(as % of GDP) of South Africa in 2006 to that in 2011?
Keep it short and to the point. 0.32. What is the ratio of the Rent(as % of GDP) in Small states in 2007 to that in 2008?
Keep it short and to the point. 0.31. What is the ratio of the Rent(as % of GDP) of Colombia in 2007 to that in 2008?
Keep it short and to the point. 0.23. What is the ratio of the Rent(as % of GDP) of Germany in 2007 to that in 2008?
Provide a succinct answer. 0.17. What is the ratio of the Rent(as % of GDP) of South Africa in 2007 to that in 2008?
Give a very brief answer. 0.31. What is the ratio of the Rent(as % of GDP) of Small states in 2007 to that in 2009?
Your answer should be very brief. 1.1. What is the ratio of the Rent(as % of GDP) of Colombia in 2007 to that in 2009?
Your answer should be compact. 1.03. What is the ratio of the Rent(as % of GDP) of Germany in 2007 to that in 2009?
Your answer should be very brief. 1.48. What is the ratio of the Rent(as % of GDP) of South Africa in 2007 to that in 2009?
Give a very brief answer. 0.95. What is the ratio of the Rent(as % of GDP) in Small states in 2007 to that in 2010?
Give a very brief answer. 0.52. What is the ratio of the Rent(as % of GDP) of Colombia in 2007 to that in 2010?
Your answer should be compact. 0.5. What is the ratio of the Rent(as % of GDP) in Germany in 2007 to that in 2010?
Offer a very short reply. 0.47. What is the ratio of the Rent(as % of GDP) of South Africa in 2007 to that in 2010?
Ensure brevity in your answer.  0.65. What is the ratio of the Rent(as % of GDP) in Small states in 2007 to that in 2011?
Provide a short and direct response. 0.41. What is the ratio of the Rent(as % of GDP) in Colombia in 2007 to that in 2011?
Give a very brief answer. 0.32. What is the ratio of the Rent(as % of GDP) of Germany in 2007 to that in 2011?
Offer a terse response. 0.22. What is the ratio of the Rent(as % of GDP) of South Africa in 2007 to that in 2011?
Make the answer very short. 0.5. What is the ratio of the Rent(as % of GDP) of Small states in 2008 to that in 2009?
Keep it short and to the point. 3.61. What is the ratio of the Rent(as % of GDP) of Colombia in 2008 to that in 2009?
Offer a very short reply. 4.46. What is the ratio of the Rent(as % of GDP) in Germany in 2008 to that in 2009?
Make the answer very short. 8.58. What is the ratio of the Rent(as % of GDP) of South Africa in 2008 to that in 2009?
Keep it short and to the point. 3.1. What is the ratio of the Rent(as % of GDP) in Small states in 2008 to that in 2010?
Make the answer very short. 1.72. What is the ratio of the Rent(as % of GDP) in Colombia in 2008 to that in 2010?
Make the answer very short. 2.16. What is the ratio of the Rent(as % of GDP) in Germany in 2008 to that in 2010?
Offer a very short reply. 2.71. What is the ratio of the Rent(as % of GDP) of South Africa in 2008 to that in 2010?
Keep it short and to the point. 2.12. What is the ratio of the Rent(as % of GDP) of Small states in 2008 to that in 2011?
Make the answer very short. 1.34. What is the ratio of the Rent(as % of GDP) in Colombia in 2008 to that in 2011?
Give a very brief answer. 1.38. What is the ratio of the Rent(as % of GDP) in Germany in 2008 to that in 2011?
Your answer should be very brief. 1.26. What is the ratio of the Rent(as % of GDP) of South Africa in 2008 to that in 2011?
Provide a short and direct response. 1.63. What is the ratio of the Rent(as % of GDP) in Small states in 2009 to that in 2010?
Your answer should be compact. 0.48. What is the ratio of the Rent(as % of GDP) of Colombia in 2009 to that in 2010?
Keep it short and to the point. 0.48. What is the ratio of the Rent(as % of GDP) in Germany in 2009 to that in 2010?
Your answer should be compact. 0.32. What is the ratio of the Rent(as % of GDP) of South Africa in 2009 to that in 2010?
Your answer should be compact. 0.69. What is the ratio of the Rent(as % of GDP) of Small states in 2009 to that in 2011?
Make the answer very short. 0.37. What is the ratio of the Rent(as % of GDP) of Colombia in 2009 to that in 2011?
Provide a short and direct response. 0.31. What is the ratio of the Rent(as % of GDP) in Germany in 2009 to that in 2011?
Make the answer very short. 0.15. What is the ratio of the Rent(as % of GDP) of South Africa in 2009 to that in 2011?
Offer a terse response. 0.53. What is the ratio of the Rent(as % of GDP) of Small states in 2010 to that in 2011?
Your response must be concise. 0.78. What is the ratio of the Rent(as % of GDP) of Colombia in 2010 to that in 2011?
Provide a short and direct response. 0.64. What is the ratio of the Rent(as % of GDP) of Germany in 2010 to that in 2011?
Keep it short and to the point. 0.47. What is the ratio of the Rent(as % of GDP) in South Africa in 2010 to that in 2011?
Your answer should be compact. 0.77. What is the difference between the highest and the second highest Rent(as % of GDP) of Small states?
Give a very brief answer. 0.02. What is the difference between the highest and the second highest Rent(as % of GDP) of Colombia?
Offer a very short reply. 0.6. What is the difference between the highest and the second highest Rent(as % of GDP) of Germany?
Your answer should be compact. 0.01. What is the difference between the highest and the second highest Rent(as % of GDP) of South Africa?
Your answer should be very brief. 2.58. What is the difference between the highest and the lowest Rent(as % of GDP) in Small states?
Offer a very short reply. 0.08. What is the difference between the highest and the lowest Rent(as % of GDP) in Colombia?
Give a very brief answer. 2.1. What is the difference between the highest and the lowest Rent(as % of GDP) of Germany?
Keep it short and to the point. 0.06. What is the difference between the highest and the lowest Rent(as % of GDP) of South Africa?
Offer a very short reply. 5.46. 